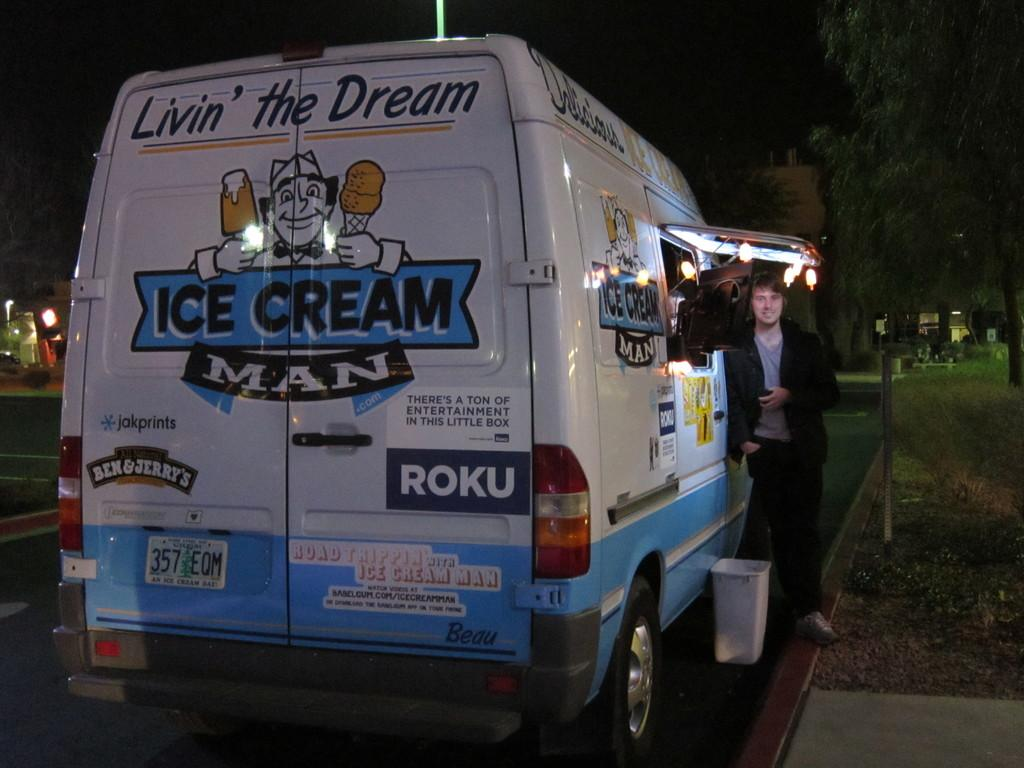<image>
Create a compact narrative representing the image presented. the word roku that is on the back of a van 